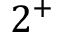Convert formula to latex. <formula><loc_0><loc_0><loc_500><loc_500>2 ^ { + }</formula> 